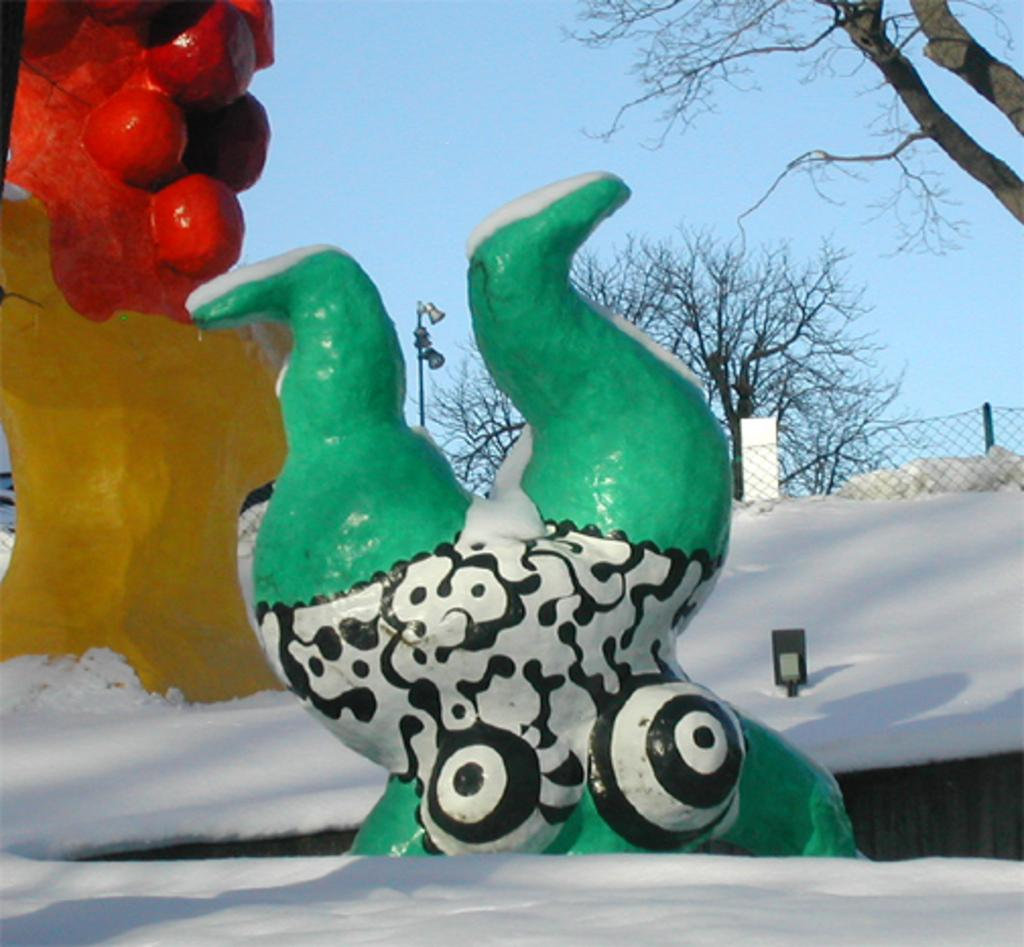What type of objects can be seen in the image? There are sculptures of different colors in the image. What is the weather like in the image? There is snow visible in the image, indicating a cold or wintry environment. What material is present in the image? There is a mesh in the image. What type of natural elements can be seen in the image? There are trees in the image. What structure is present in the image? There is a pole in the image. What color is the sky in the image? The sky is pale blue in the image. How many birds are perched on the sculptures in the image? There are no birds present in the image; it only features sculptures, snow, a mesh, trees, a pole, and a pale blue sky. 